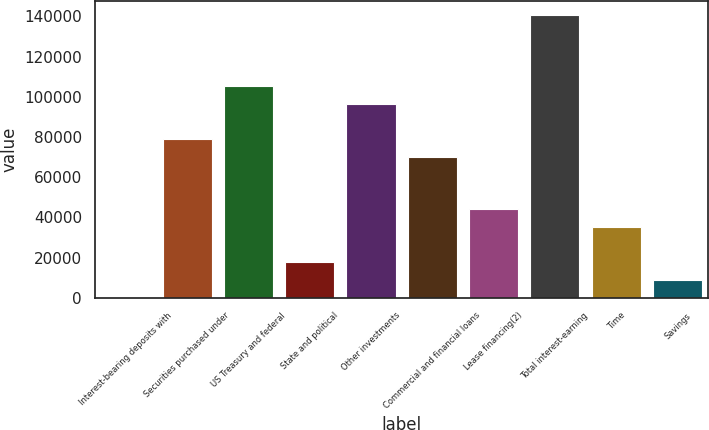Convert chart. <chart><loc_0><loc_0><loc_500><loc_500><bar_chart><fcel>Interest-bearing deposits with<fcel>Securities purchased under<fcel>US Treasury and federal<fcel>State and political<fcel>Other investments<fcel>Commercial and financial loans<fcel>Lease financing(2)<fcel>Total interest-earning<fcel>Time<fcel>Savings<nl><fcel>74<fcel>79014.8<fcel>105328<fcel>17616.4<fcel>96557.2<fcel>70243.6<fcel>43930<fcel>140413<fcel>35158.8<fcel>8845.2<nl></chart> 